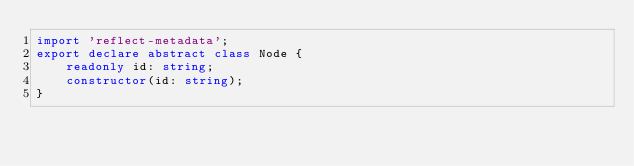Convert code to text. <code><loc_0><loc_0><loc_500><loc_500><_TypeScript_>import 'reflect-metadata';
export declare abstract class Node {
    readonly id: string;
    constructor(id: string);
}
</code> 